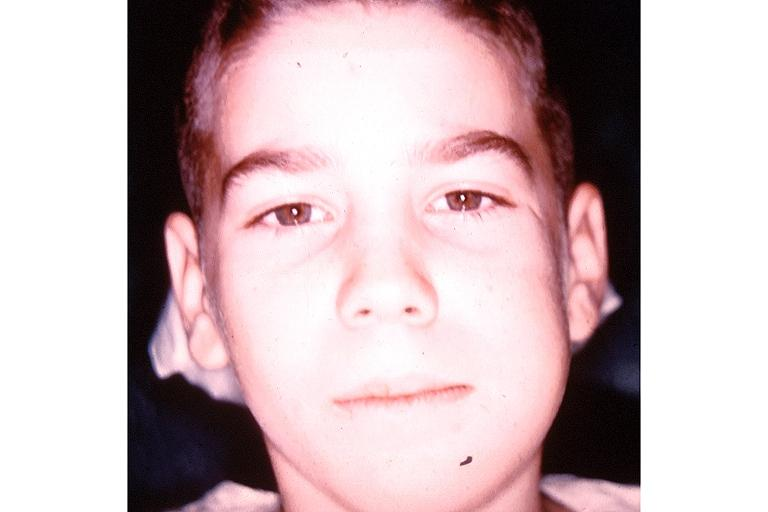what does this image show?
Answer the question using a single word or phrase. Garres osteomyelitis proliferative periosteitis 